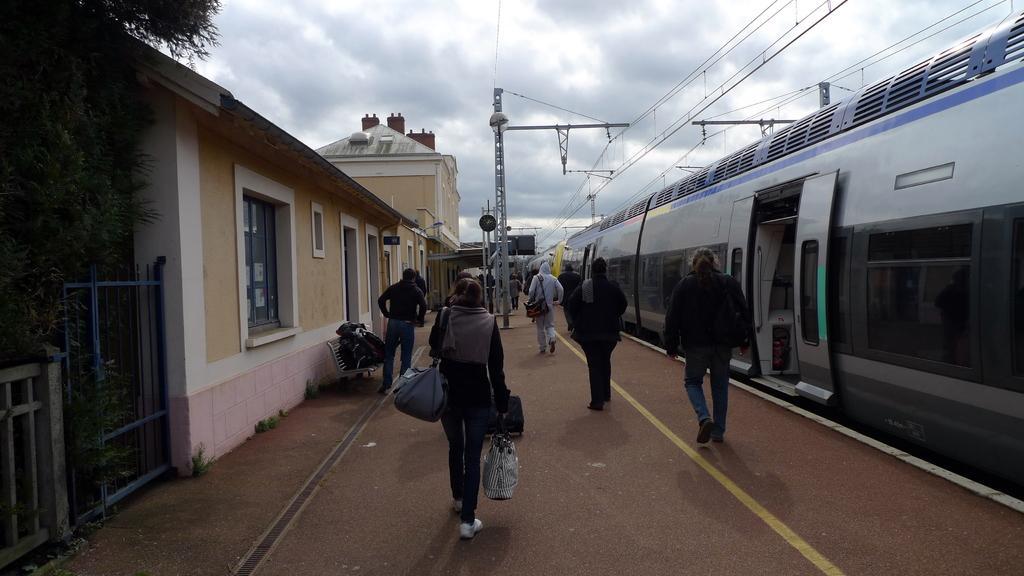Could you give a brief overview of what you see in this image? In this image we can see the building, one train on the track, some people are walking, few people are wearing bags, one woman holding an object in the middle of the image, one fence, one gate, some objects attached to the building, one object on the floor, one bench, some objects on the bench, some objects attached to the poles, some wires, two boards, some poles, some trees, plants and grass on the ground. At the top there is the cloudy sky.  